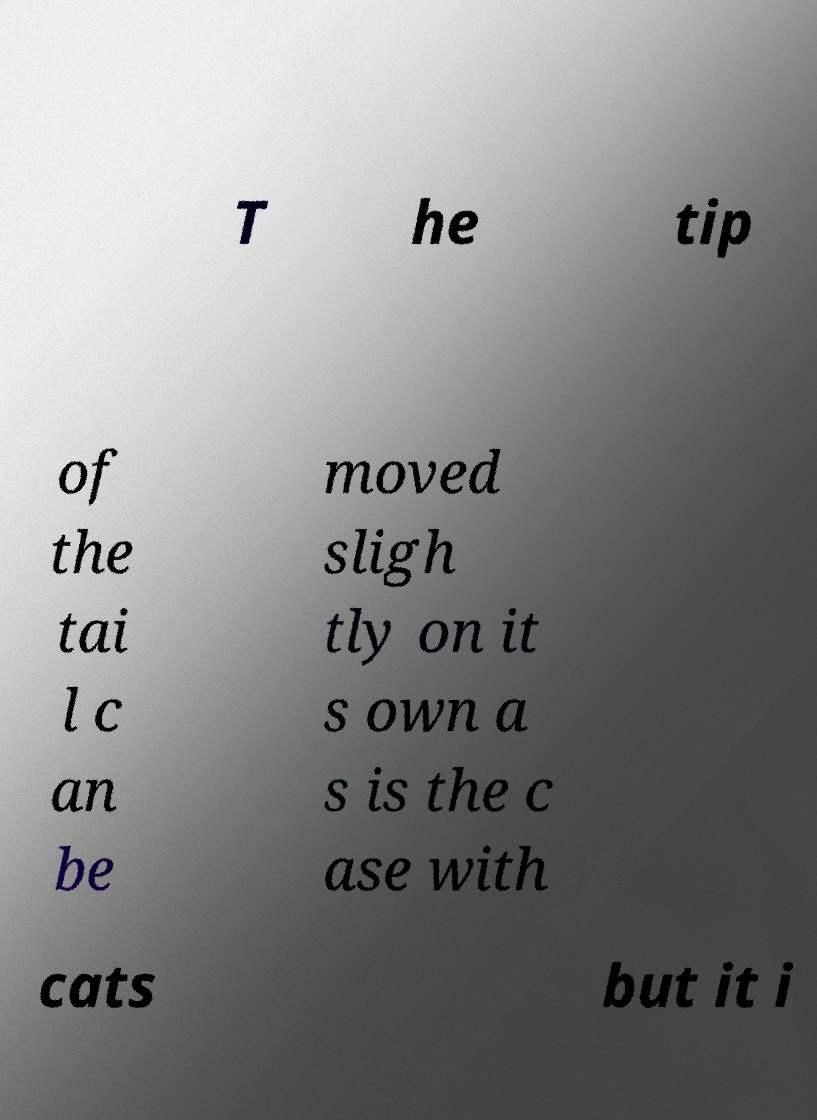What messages or text are displayed in this image? I need them in a readable, typed format. T he tip of the tai l c an be moved sligh tly on it s own a s is the c ase with cats but it i 